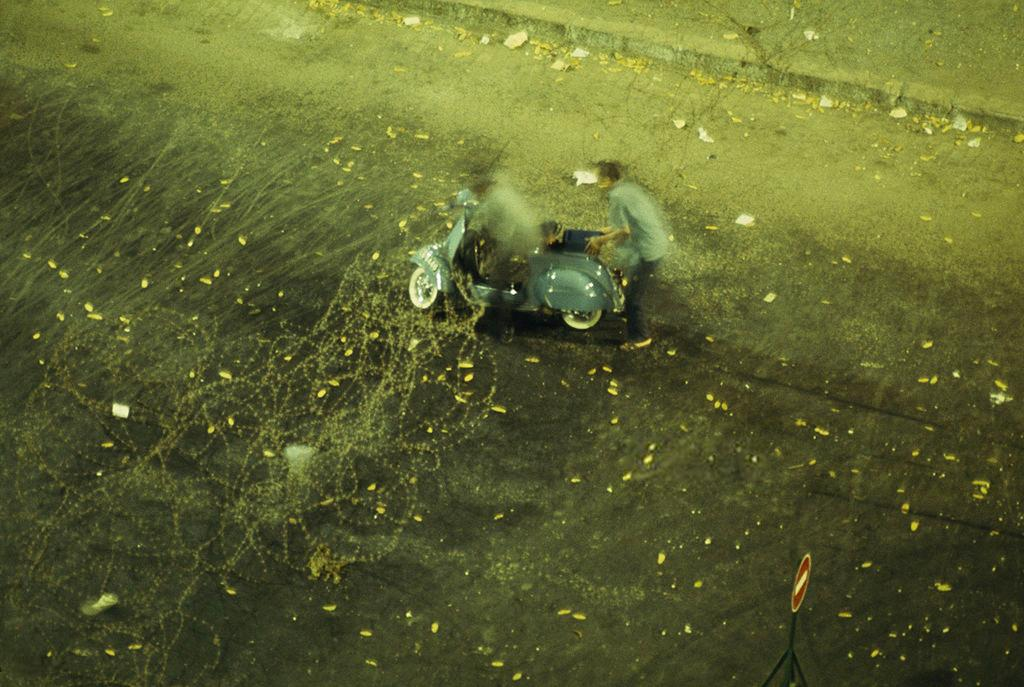What is the person in the image holding? The person is holding a vehicle in the image. What color is the vehicle? The vehicle is blue. What else can be seen in the image besides the person and the vehicle? There is a signboard, leaves, and papers on the road in the image. What type of support can be seen at the party in the image? There is no party or support present in the image. What calculations can be made using the calculator in the image? There is no calculator present in the image. 